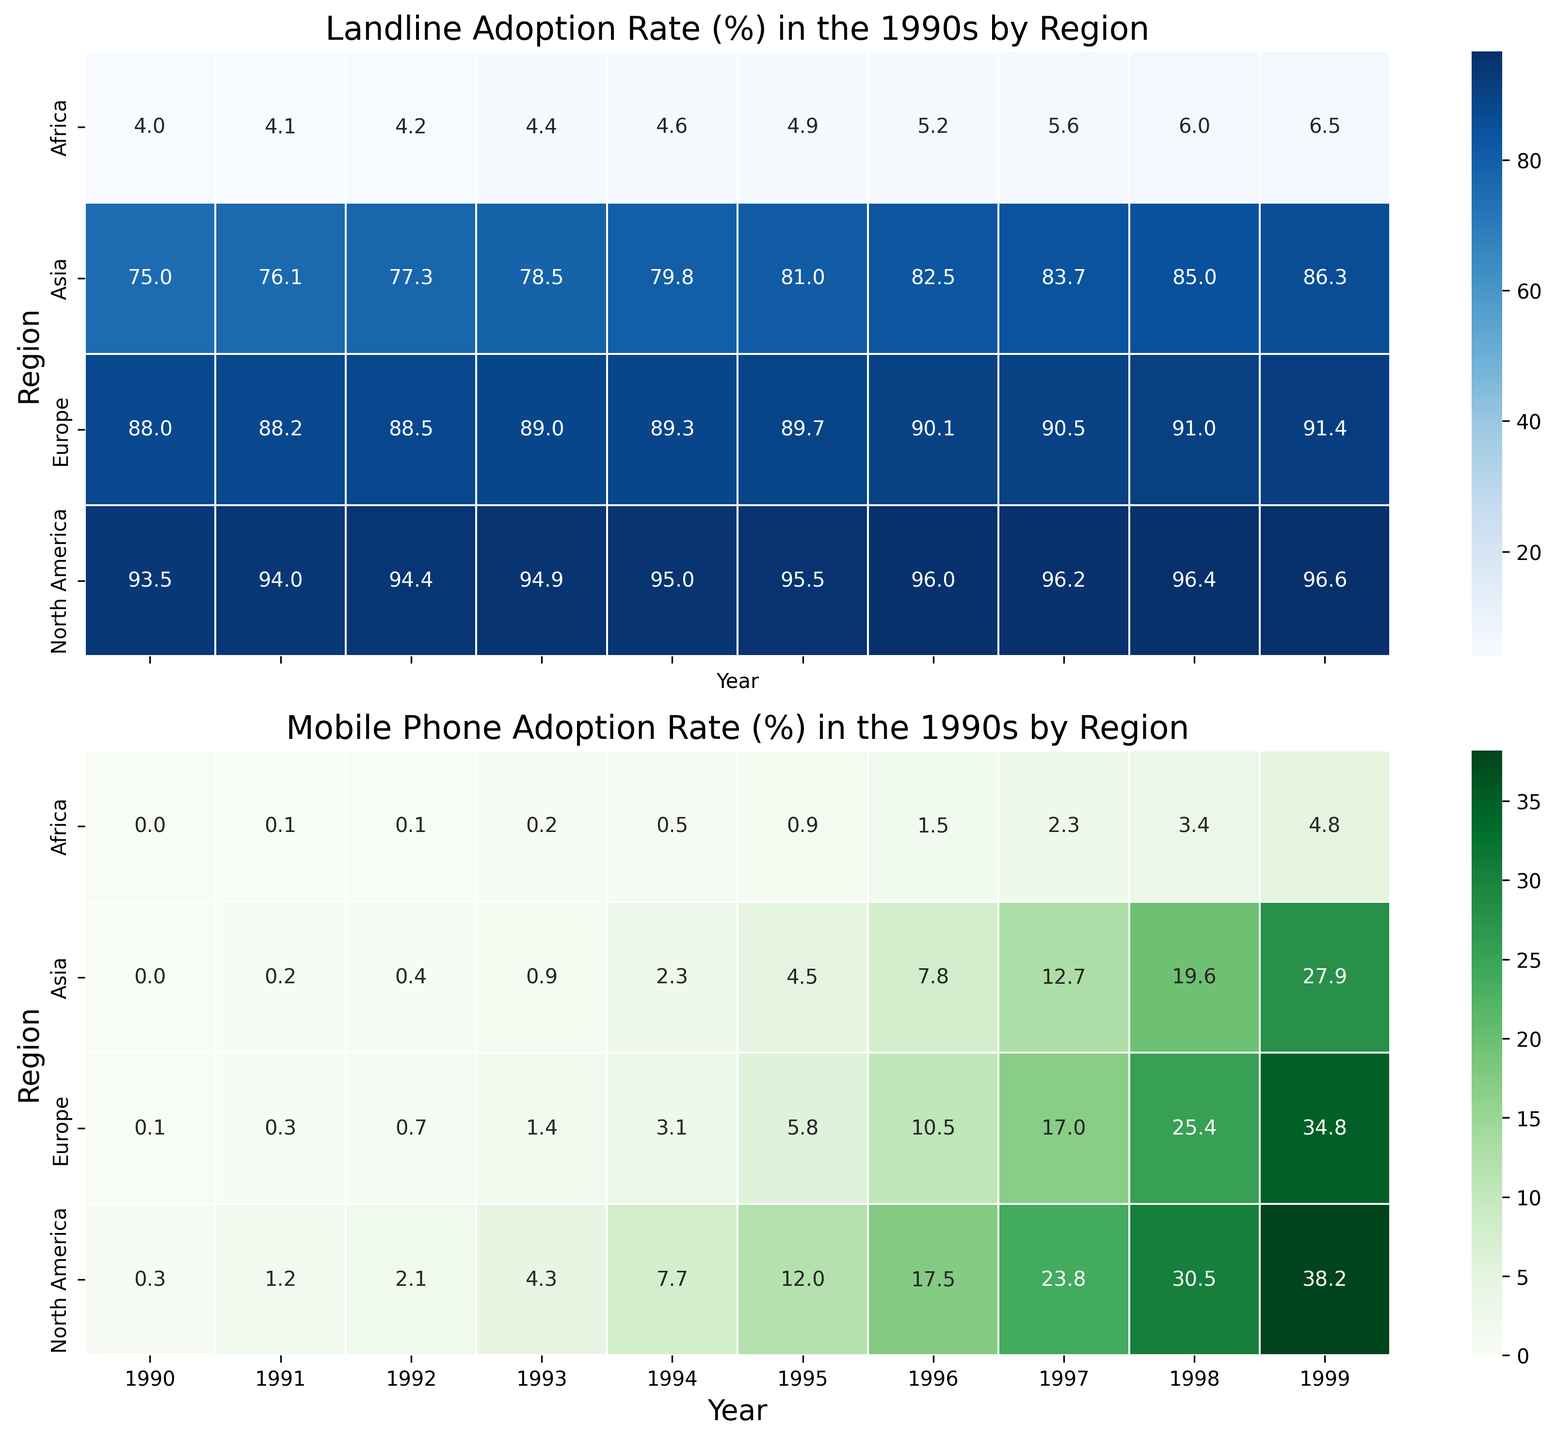What's the trend in landline adoption rates in North America over the 1990s? To answer this, look at the first heatmap. Observe the increment in landline adoption rate in the 1990s across years for North America. The years act as the x-axis while the regions, including North America, are the y-axis. You'll notice that the adoption rates start at 93.5% in 1990 and gradually increase each year, ending at 96.6% in 1999.
Answer: Increasing trend Which region had the highest mobile phone adoption rate by the end of the 1990s? Focus on the second heatmap showing mobile phone adoption rates. Look at the year 1999 along the x-axis and compare the adoption rates across different regions on the y-axis. North America shows a rate of 38.2%, Europe has 34.8%, Asia has 27.9%, and Africa has 4.8%. Thus, North America had the highest adoption rate by the end of the decade.
Answer: North America By how much did the mobile phone adoption rate in Europe increase from 1990 to 1999? Refer to the second heatmap. Locate Europe on the y-axis and note the values for 1990 and 1999 along the x-axis. The adoption rate in 1990 is 0.1% and in 1999 it is 34.8%. The increase is 34.8% - 0.1% = 34.7%.
Answer: 34.7% Compare the landline adoption rate in Asia and Africa in the year 1995. Which region had a higher rate? Check the first heatmap for the year 1995. Compare the values for Asia and Africa. For 1995, Asia has a rate of 81.0% while Africa has a rate of 4.9%. Thus, Asia had a higher landline adoption rate.
Answer: Asia What can be inferred about the overall mobile phone adoption trend in Africa throughout the 1990s? Examine the second heatmap specifically for the row corresponding to Africa. Observe the yearly values. Starting at 0.0% in 1990, the rate increases each year, ending at 4.8% in 1999. Although the increase is gradual and the rates are relatively low compared to other regions, the trend is an upward one.
Answer: Upward trend, but low adoption rate Which year marked a significant increase in mobile phone adoption rates in North America? Look closely at the second heatmap for North America. There is a notable increase in more recent years of the decade. The adoption rate jumps significantly from 4.3% in 1993 to 7.7% in 1994. However, an even more significant jump is seen from 17.5% in 1996 to 23.8% in 1997. These years mark significant increases.
Answer: 1997 What were the landline adoption rates for North America, Europe, and Asia in the middle of the decade (1995)? Refer to the first heatmap and locate the column for 1995. Check the values corresponding to North America, Europe, and Asia. North America's value is 95.5%, Europe's is 89.7%, and Asia's is 81.0%.
Answer: North America: 95.5%, Europe: 89.7%, Asia: 81.0% Considering both heatmaps, which region showed the most consistent increase in mobile phone adoption rates in the 1990s? Examine the second heatmap. Compare the yearly increments across different regions. Africa shows the most consistent pattern of increasing rates, with a steady rise every year, albeit the rates are low. This is a more uniform increase compared to other regions that show some larger annual jumps.
Answer: Africa 